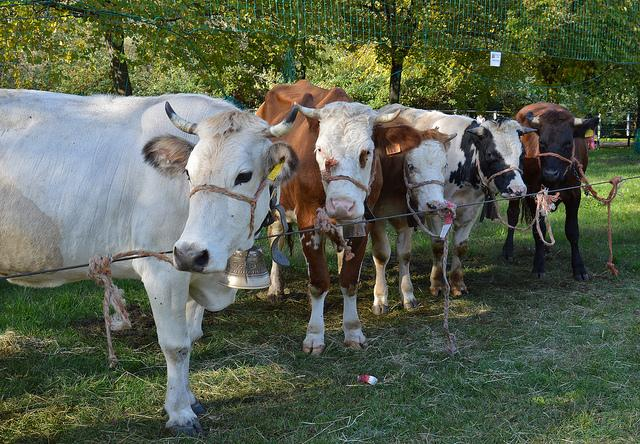What is the most common breed of milk cow? holstein 